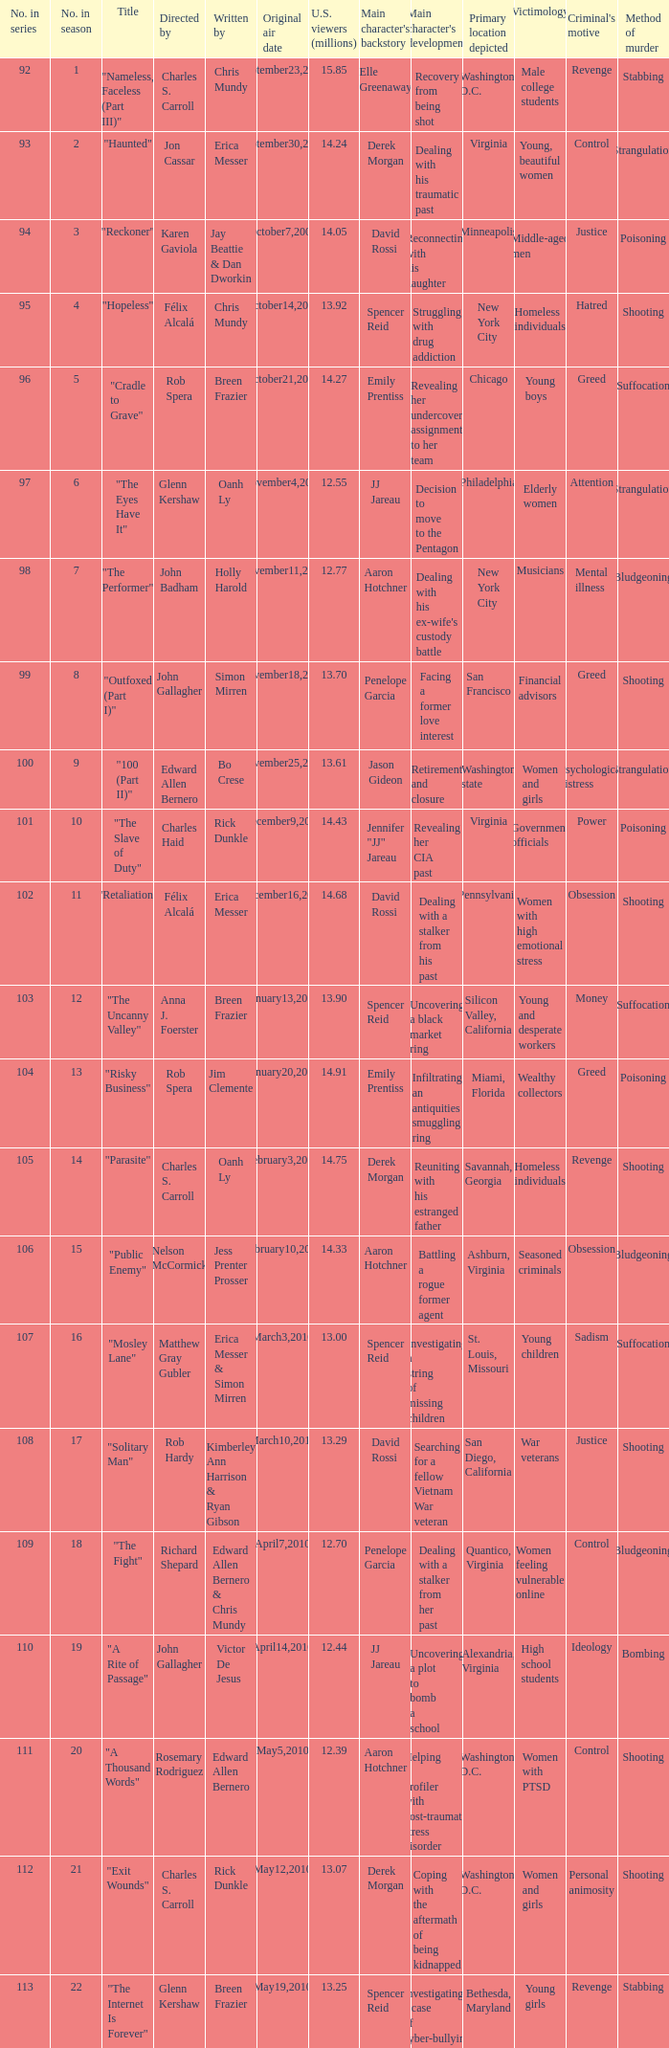What number(s) in the series was written by bo crese? 100.0. 